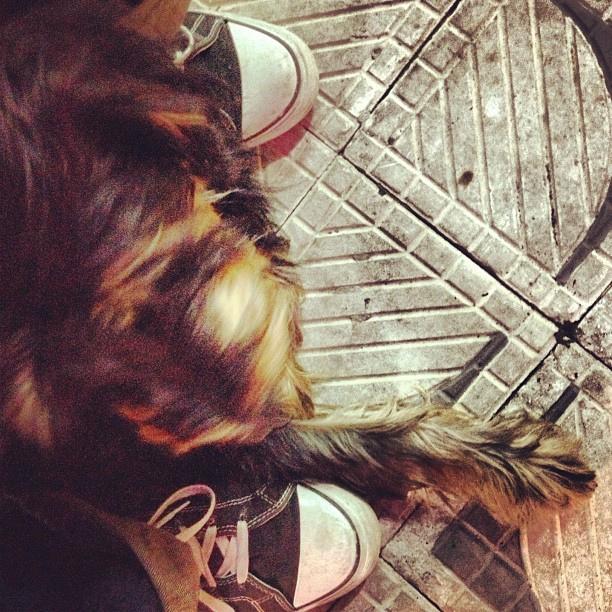Is the surface shown dirty?
Keep it brief. Yes. Is the person in this photo barefoot?
Short answer required. No. What animal is in this picture?
Write a very short answer. Dog. 